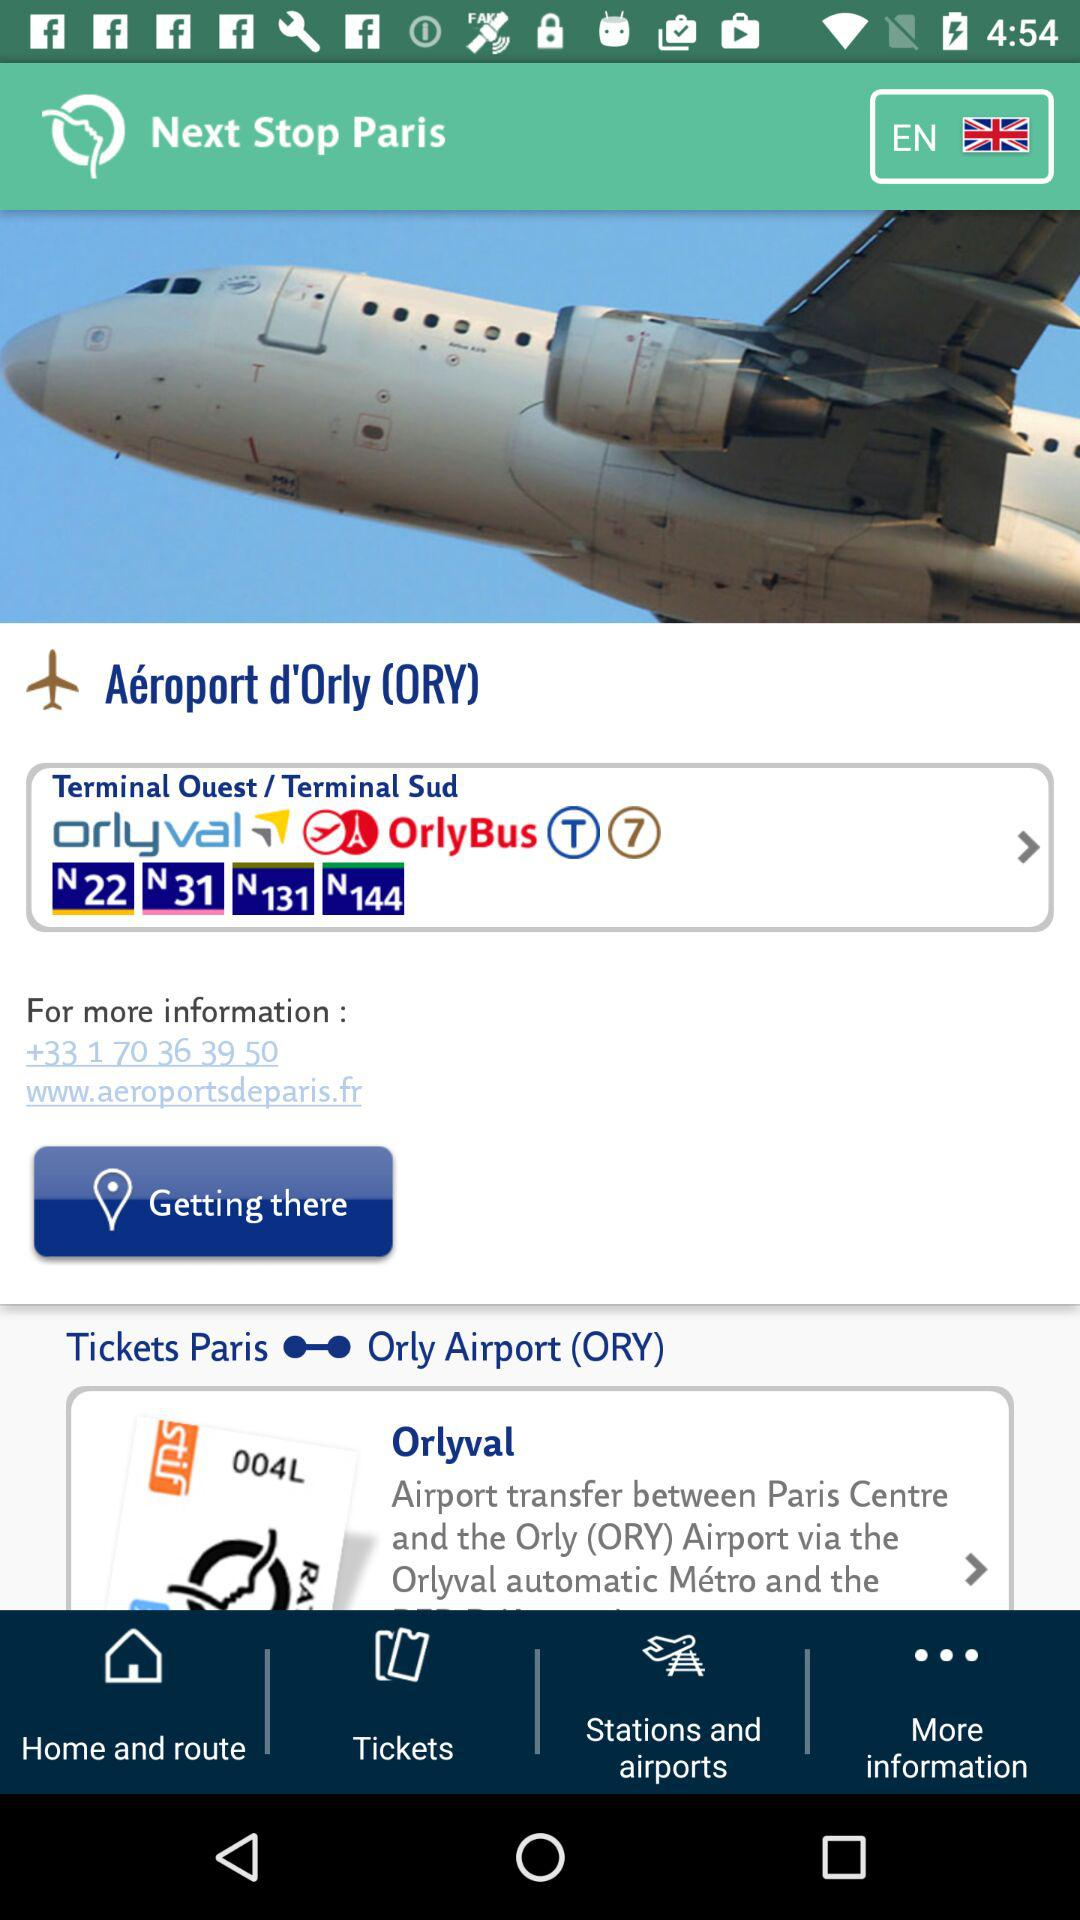What is the contact number given here? The contact number is +33 1 70 36 39 50. 